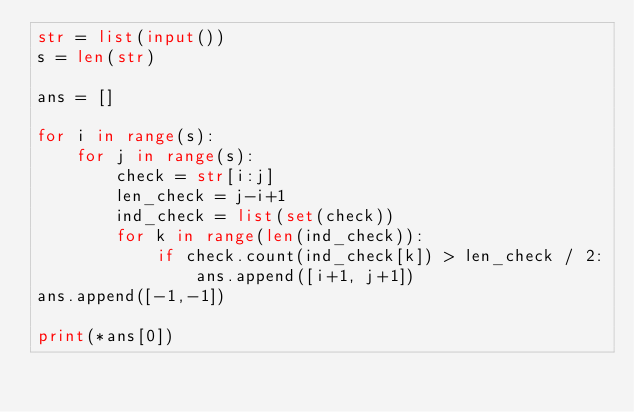Convert code to text. <code><loc_0><loc_0><loc_500><loc_500><_Python_>str = list(input())
s = len(str)

ans = []

for i in range(s):
	for j in range(s):
		check = str[i:j]
		len_check = j-i+1
		ind_check = list(set(check))
		for k in range(len(ind_check)):
			if check.count(ind_check[k]) > len_check / 2:
				ans.append([i+1, j+1])
ans.append([-1,-1])

print(*ans[0])</code> 